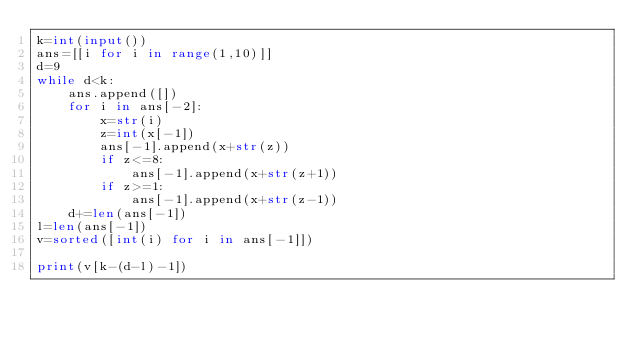<code> <loc_0><loc_0><loc_500><loc_500><_Python_>k=int(input())
ans=[[i for i in range(1,10)]]
d=9
while d<k:
    ans.append([])
    for i in ans[-2]:
        x=str(i)
        z=int(x[-1])
        ans[-1].append(x+str(z))
        if z<=8:
            ans[-1].append(x+str(z+1))
        if z>=1:
            ans[-1].append(x+str(z-1))
    d+=len(ans[-1])
l=len(ans[-1])
v=sorted([int(i) for i in ans[-1]])

print(v[k-(d-l)-1])</code> 